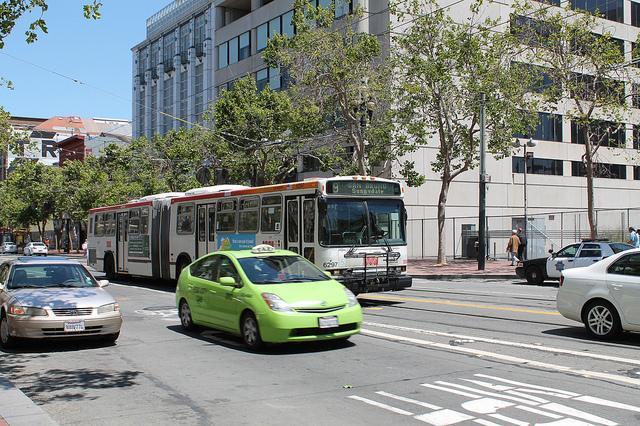Why is one car such a bright unusual color?
From the following four choices, select the correct answer to address the question.
Options: Taxi, fashionable, highlighter company, promotion. Taxi. 